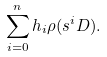<formula> <loc_0><loc_0><loc_500><loc_500>\sum _ { i = 0 } ^ { n } h _ { i } \rho ( s ^ { i } D ) .</formula> 